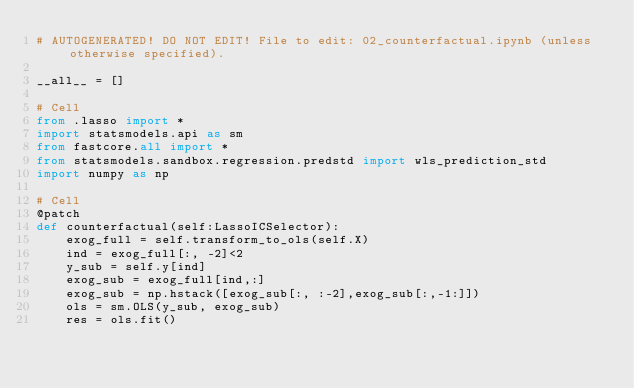<code> <loc_0><loc_0><loc_500><loc_500><_Python_># AUTOGENERATED! DO NOT EDIT! File to edit: 02_counterfactual.ipynb (unless otherwise specified).

__all__ = []

# Cell
from .lasso import *
import statsmodels.api as sm
from fastcore.all import *
from statsmodels.sandbox.regression.predstd import wls_prediction_std
import numpy as np

# Cell
@patch
def counterfactual(self:LassoICSelector):
    exog_full = self.transform_to_ols(self.X)
    ind = exog_full[:, -2]<2
    y_sub = self.y[ind]
    exog_sub = exog_full[ind,:]
    exog_sub = np.hstack([exog_sub[:, :-2],exog_sub[:,-1:]])
    ols = sm.OLS(y_sub, exog_sub)
    res = ols.fit()</code> 